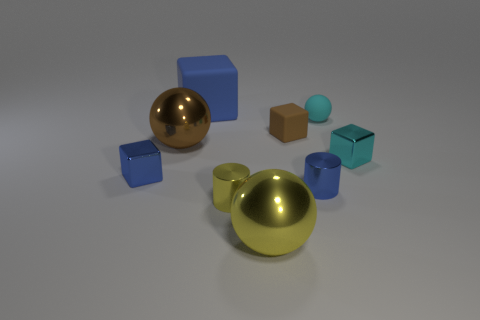Subtract all balls. How many objects are left? 6 Subtract all large green balls. Subtract all small brown objects. How many objects are left? 8 Add 2 small blue cubes. How many small blue cubes are left? 3 Add 4 big gray cubes. How many big gray cubes exist? 4 Subtract 0 gray cylinders. How many objects are left? 9 